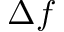Convert formula to latex. <formula><loc_0><loc_0><loc_500><loc_500>\Delta f</formula> 